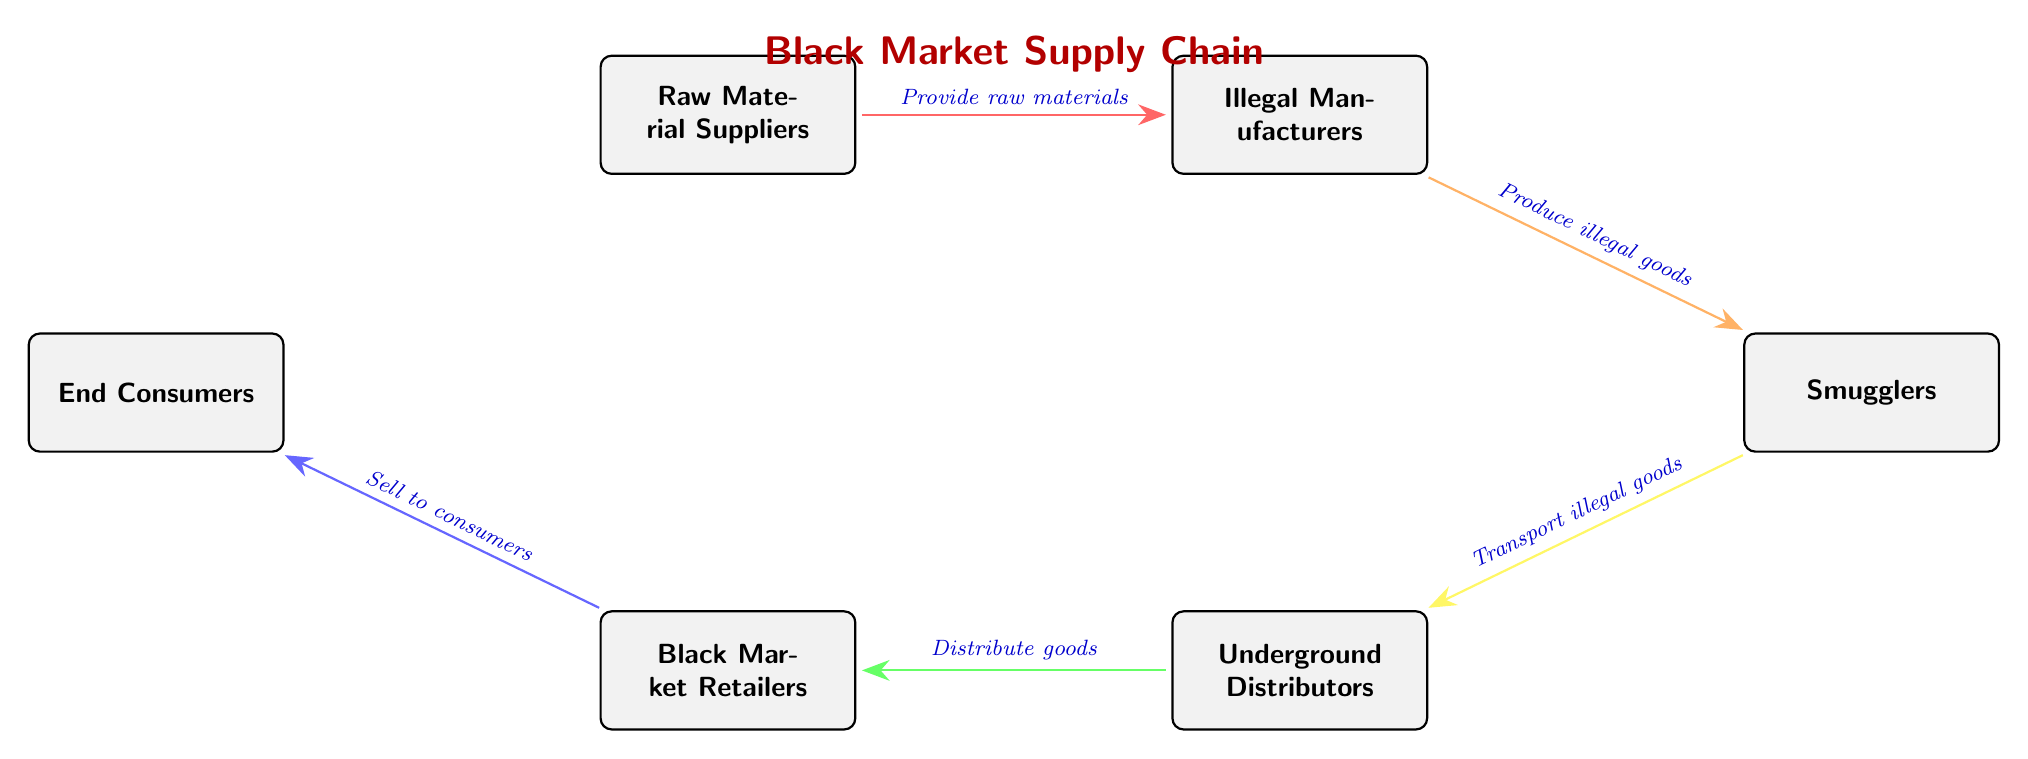What is the first node in the supply chain? The first node in the supply chain is identified as "Raw Material Suppliers," which is located at the top of the diagram. It serves as the initial source of raw materials for the subsequent nodes.
Answer: Raw Material Suppliers How many nodes are in the supply chain? By counting each distinct box in the diagram, we find there are a total of five nodes that represent different stages in the black market supply chain.
Answer: Five What do Illegal Manufacturers provide to Smugglers? According to the diagram, Illegal Manufacturers produce illegal goods, which are then supplied to Smugglers, as indicated by the arrow connecting these two nodes.
Answer: Produce illegal goods Which node is connected to Underground Distributors? The Underground Distributors node is connected to the Smugglers node, as shown by the arrow indicating the flow of illegal goods from Smugglers to Underground Distributors in the diagram.
Answer: Smugglers What is the final destination of the supply chain? The final destination of the supply chain is labeled "End Consumers," which is the last node in the diagram where the goods ultimately reach.
Answer: End Consumers What is the relationship between Black Market Retailers and End Consumers? The connection between Black Market Retailers and End Consumers is that Black Market Retailers sell the illegal goods to End Consumers, as indicated by the arrow and the label describing the action.
Answer: Sell to consumers Which node acts as a distributor in the supply chain? The node that functions as a distributor in the supply chain is "Underground Distributors," which is tasked with distributing the illegal goods to retailers as illustrated in the diagram.
Answer: Underground Distributors What type of goods do Smugglers transport? Smugglers are responsible for transporting illegal goods, as indicated in the diagram by the label on the arrow that connects Smugglers to Underground Distributors.
Answer: Illegal goods What color represents the arrows indicating the flow from Illegal Manufacturers to Smugglers? The flow from Illegal Manufacturers to Smugglers is represented by an orange arrow in the diagram, noted by the specific color used for that connection.
Answer: Orange 